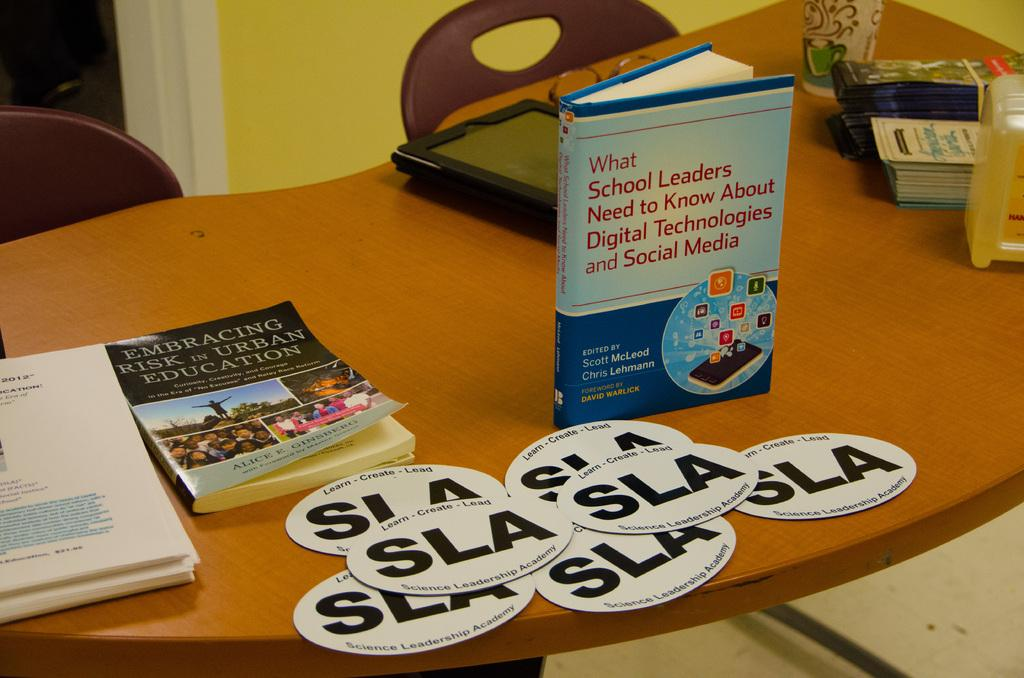<image>
Provide a brief description of the given image. White circles saying "SLA" on top of a table. 